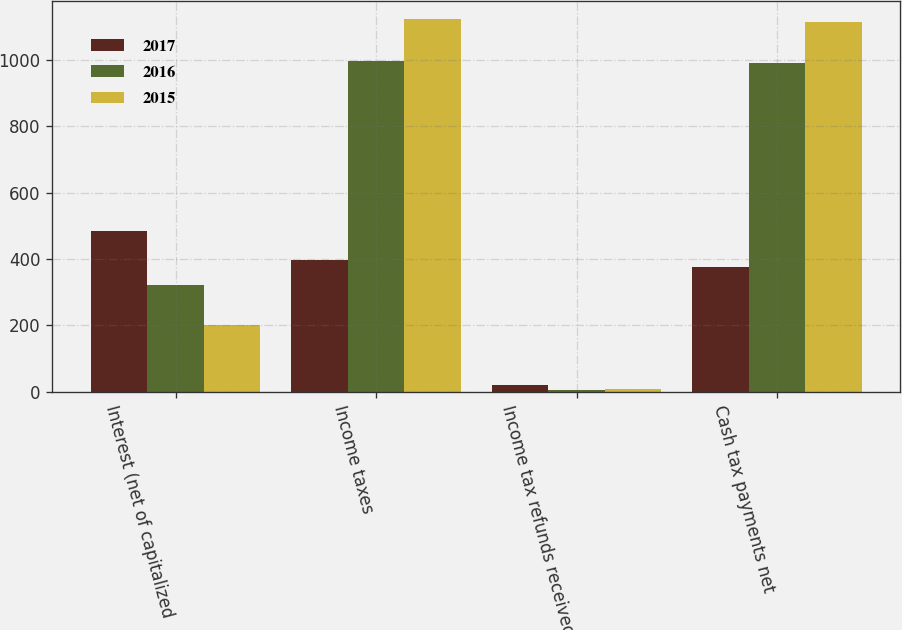Convert chart. <chart><loc_0><loc_0><loc_500><loc_500><stacked_bar_chart><ecel><fcel>Interest (net of capitalized<fcel>Income taxes<fcel>Income tax refunds received<fcel>Cash tax payments net<nl><fcel>2017<fcel>484<fcel>397<fcel>20<fcel>377<nl><fcel>2016<fcel>321<fcel>996<fcel>5<fcel>991<nl><fcel>2015<fcel>201<fcel>1122<fcel>9<fcel>1113<nl></chart> 